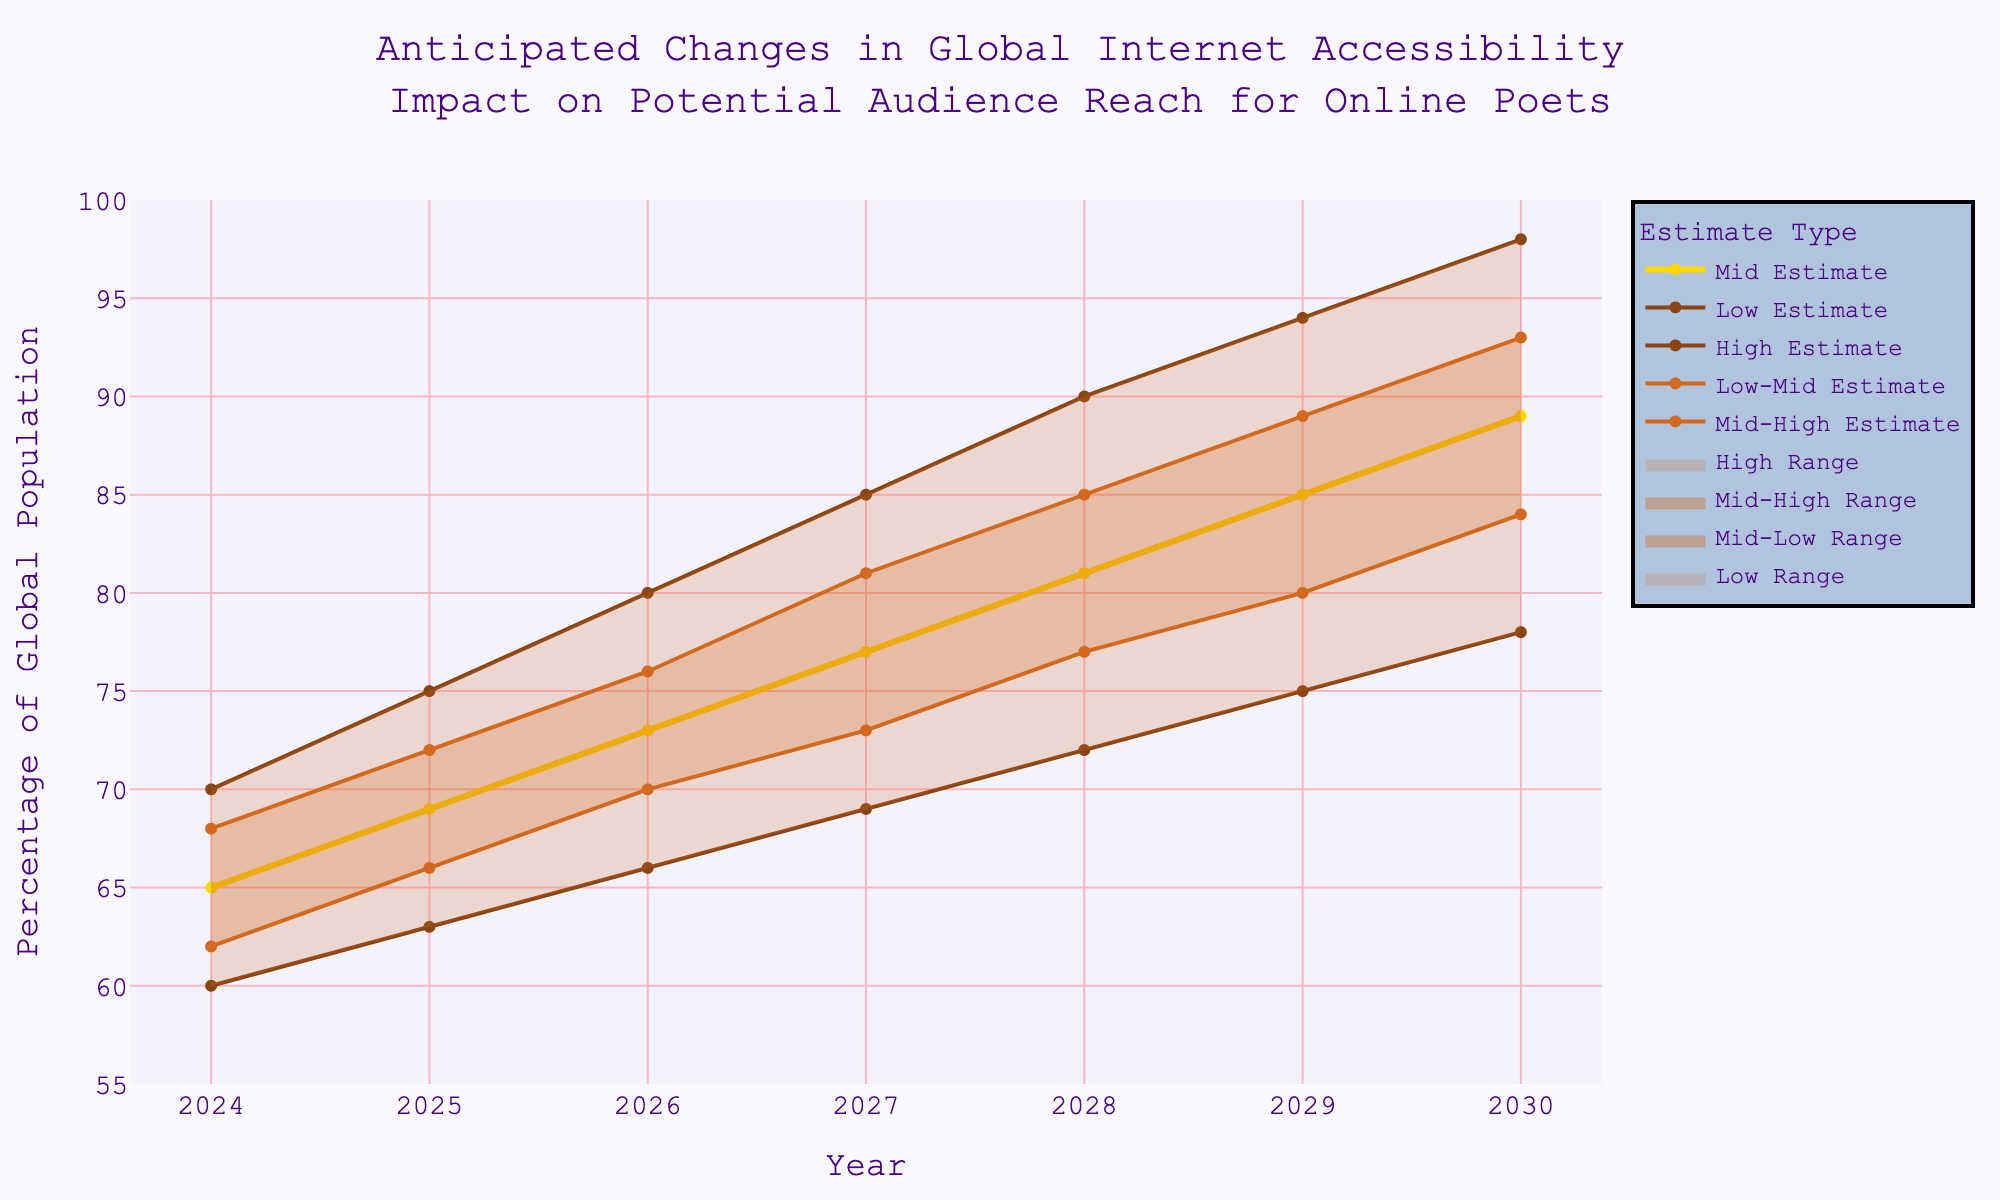What is the title of the chart? The title is displayed at the top of the chart. It reads, "Anticipated Changes in Global Internet Accessibility Impact on Potential Audience Reach for Online Poets."
Answer: Anticipated Changes in Global Internet Accessibility Impact on Potential Audience Reach for Online Poets How many years of data are represented in the chart? The x-axis represents the years, starting from 2024 and ending at 2030. Counting the years gives us 7 data points.
Answer: 7 During which year does the Low Estimate cross 70%? Checking the values for the Low Estimate, it crosses 70% in the year 2028.
Answer: 2028 What is the range of the Mid Estimate from 2024 to 2030? The Mid Estimate starts at 65% in 2024 and ends at 89% in 2030. The range can be calculated by subtracting the starting value from the ending value, 89% - 65% = 24%.
Answer: 24% By how much does the High Estimate increase from 2024 to 2029? The High Estimate starts at 70% in 2024 and increases to 94% in 2029. The increase is calculated as 94% - 70% = 24%.
Answer: 24% Which estimate shows the smallest increase from 2024 to 2030? Comparing the estimates, the Low Estimate increases from 60% to 78%, a difference of 18%. The Low-Mid Estimate increases from 62% to 84%, a difference of 22%. The Mid Estimate increases from 65% to 89%, a difference of 24%. The Mid-High Estimate increases from 68% to 93%, a difference of 25%. The High Estimate increases from 70% to 98%, a difference of 28%. Thus, the Low Estimate shows the smallest increase.
Answer: Low Estimate In which year is the difference between the High Estimate and Low Estimate the greatest? The differences for each year are: 2024: 70%-60%=10, 2025: 75%-63%=12, 2026: 80%-66%=14, 2027: 85%-69%=16, 2028: 90%-72%=18, 2029: 94%-75%=19, and 2030: 98%-78%=20. The greatest difference is in 2030.
Answer: 2030 What is the average of the Mid-High Estimate values for the given years? The values for the Mid-High Estimate from 2024 to 2030 are: 68, 72, 76, 81, 85, 89, and 93. The sum of these values is 564. Dividing by 7 gives the average: 564 / 7 = 80.57.
Answer: 80.57 In 2027, which estimate is closest to the midpoint of all the estimates for that year? The estimates for 2027 are Low: 69, Low-Mid: 73, Mid: 77, Mid-High: 81, High: 85. The midpoint is calculated by averaging the highest and lowest values ((85+69)/2=77). The Mid Estimate is already 77, which is exactly the midpoint.
Answer: Mid Estimate 